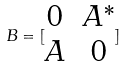<formula> <loc_0><loc_0><loc_500><loc_500>B = [ \begin{matrix} 0 & A ^ { * } \\ A & 0 \end{matrix} ]</formula> 